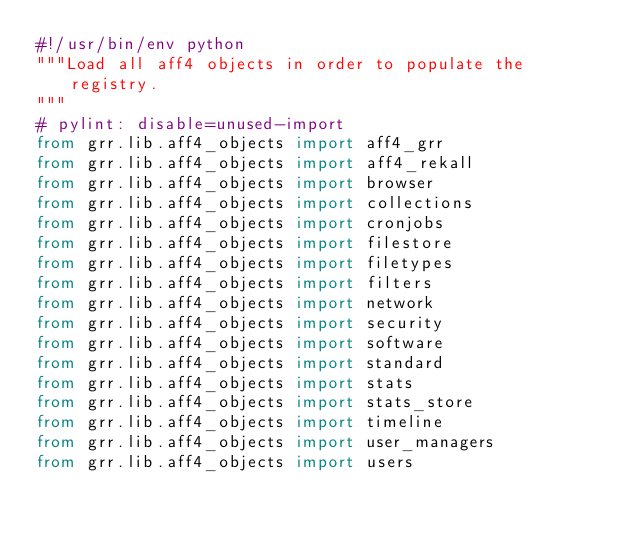Convert code to text. <code><loc_0><loc_0><loc_500><loc_500><_Python_>#!/usr/bin/env python
"""Load all aff4 objects in order to populate the registry.
"""
# pylint: disable=unused-import
from grr.lib.aff4_objects import aff4_grr
from grr.lib.aff4_objects import aff4_rekall
from grr.lib.aff4_objects import browser
from grr.lib.aff4_objects import collections
from grr.lib.aff4_objects import cronjobs
from grr.lib.aff4_objects import filestore
from grr.lib.aff4_objects import filetypes
from grr.lib.aff4_objects import filters
from grr.lib.aff4_objects import network
from grr.lib.aff4_objects import security
from grr.lib.aff4_objects import software
from grr.lib.aff4_objects import standard
from grr.lib.aff4_objects import stats
from grr.lib.aff4_objects import stats_store
from grr.lib.aff4_objects import timeline
from grr.lib.aff4_objects import user_managers
from grr.lib.aff4_objects import users
</code> 